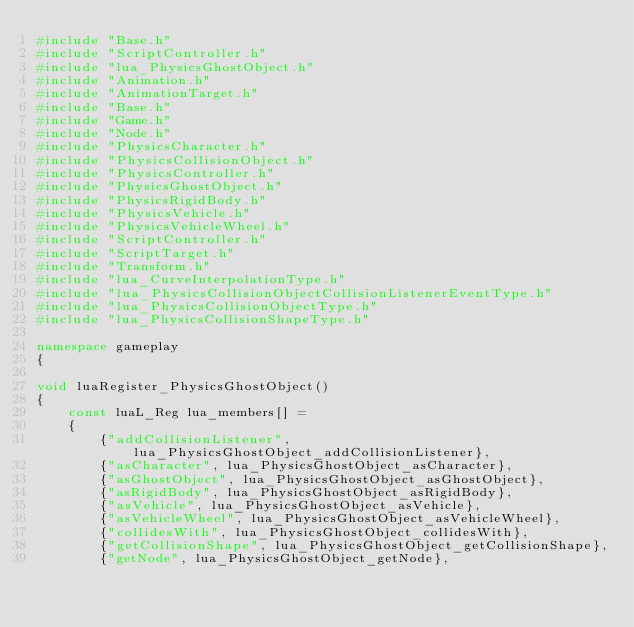<code> <loc_0><loc_0><loc_500><loc_500><_C++_>#include "Base.h"
#include "ScriptController.h"
#include "lua_PhysicsGhostObject.h"
#include "Animation.h"
#include "AnimationTarget.h"
#include "Base.h"
#include "Game.h"
#include "Node.h"
#include "PhysicsCharacter.h"
#include "PhysicsCollisionObject.h"
#include "PhysicsController.h"
#include "PhysicsGhostObject.h"
#include "PhysicsRigidBody.h"
#include "PhysicsVehicle.h"
#include "PhysicsVehicleWheel.h"
#include "ScriptController.h"
#include "ScriptTarget.h"
#include "Transform.h"
#include "lua_CurveInterpolationType.h"
#include "lua_PhysicsCollisionObjectCollisionListenerEventType.h"
#include "lua_PhysicsCollisionObjectType.h"
#include "lua_PhysicsCollisionShapeType.h"

namespace gameplay
{

void luaRegister_PhysicsGhostObject()
{
    const luaL_Reg lua_members[] = 
    {
        {"addCollisionListener", lua_PhysicsGhostObject_addCollisionListener},
        {"asCharacter", lua_PhysicsGhostObject_asCharacter},
        {"asGhostObject", lua_PhysicsGhostObject_asGhostObject},
        {"asRigidBody", lua_PhysicsGhostObject_asRigidBody},
        {"asVehicle", lua_PhysicsGhostObject_asVehicle},
        {"asVehicleWheel", lua_PhysicsGhostObject_asVehicleWheel},
        {"collidesWith", lua_PhysicsGhostObject_collidesWith},
        {"getCollisionShape", lua_PhysicsGhostObject_getCollisionShape},
        {"getNode", lua_PhysicsGhostObject_getNode},</code> 